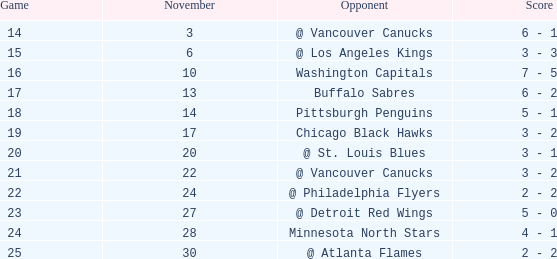Who is the opponent on november 24? @ Philadelphia Flyers. 